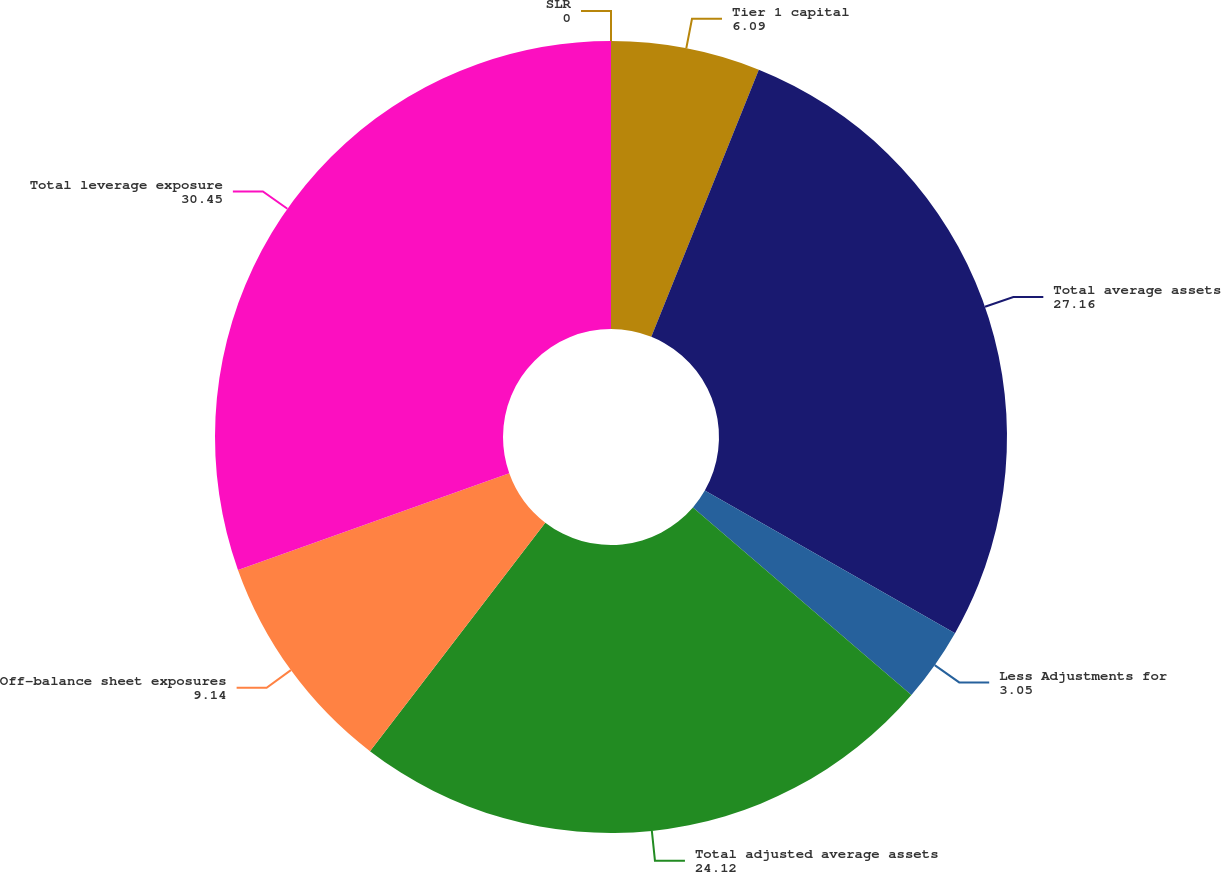<chart> <loc_0><loc_0><loc_500><loc_500><pie_chart><fcel>Tier 1 capital<fcel>Total average assets<fcel>Less Adjustments for<fcel>Total adjusted average assets<fcel>Off-balance sheet exposures<fcel>Total leverage exposure<fcel>SLR<nl><fcel>6.09%<fcel>27.16%<fcel>3.05%<fcel>24.12%<fcel>9.14%<fcel>30.45%<fcel>0.0%<nl></chart> 